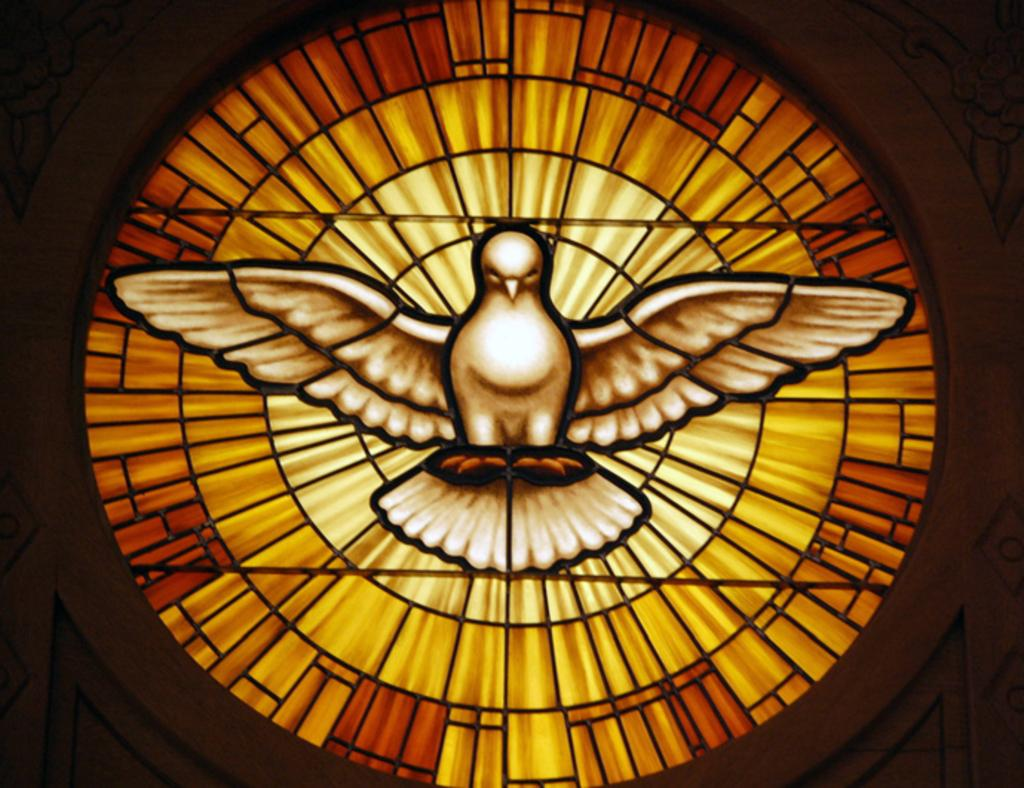What is the main subject of the picture? The main subject of the picture is an image of a bird. Can you describe the bird's appearance? The bird is white in color. Are there any other objects or elements in the image besides the bird? Yes, there are other objects beside the bird in the image. What type of polish is the bird using on its nails in the image? There is no indication in the image that the bird is using polish or has nails, as it is a bird and not a human. 